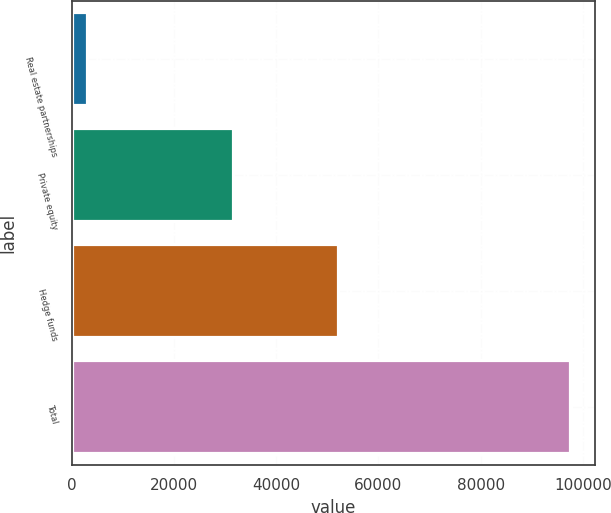<chart> <loc_0><loc_0><loc_500><loc_500><bar_chart><fcel>Real estate partnerships<fcel>Private equity<fcel>Hedge funds<fcel>Total<nl><fcel>2905<fcel>31484<fcel>52114<fcel>97428<nl></chart> 